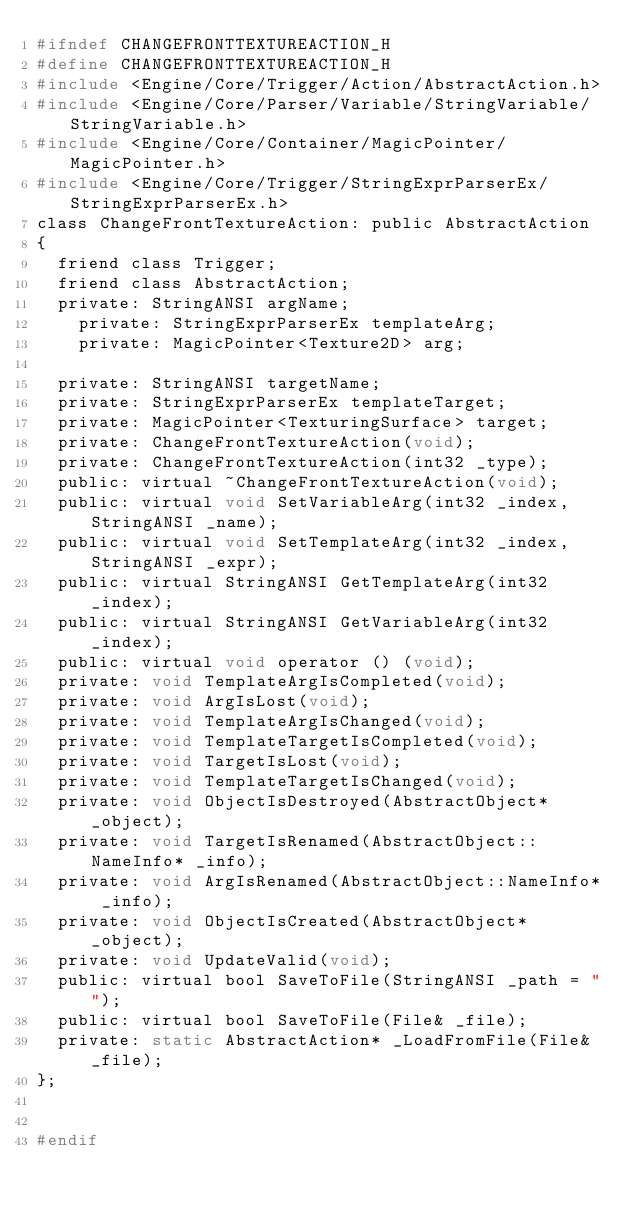Convert code to text. <code><loc_0><loc_0><loc_500><loc_500><_C_>#ifndef CHANGEFRONTTEXTUREACTION_H
#define CHANGEFRONTTEXTUREACTION_H
#include <Engine/Core/Trigger/Action/AbstractAction.h>
#include <Engine/Core/Parser/Variable/StringVariable/StringVariable.h>
#include <Engine/Core/Container/MagicPointer/MagicPointer.h>
#include <Engine/Core/Trigger/StringExprParserEx/StringExprParserEx.h>
class ChangeFrontTextureAction: public AbstractAction
{
	friend class Trigger;
	friend class AbstractAction;
	private: StringANSI argName;
    private: StringExprParserEx templateArg;
    private: MagicPointer<Texture2D> arg;

	private: StringANSI targetName;
	private: StringExprParserEx templateTarget;
	private: MagicPointer<TexturingSurface> target;
	private: ChangeFrontTextureAction(void);
	private: ChangeFrontTextureAction(int32 _type);
	public: virtual ~ChangeFrontTextureAction(void);
	public: virtual void SetVariableArg(int32 _index, StringANSI _name);
	public: virtual void SetTemplateArg(int32 _index, StringANSI _expr);
	public: virtual StringANSI GetTemplateArg(int32 _index);
	public: virtual StringANSI GetVariableArg(int32 _index);
	public: virtual void operator () (void);
	private: void TemplateArgIsCompleted(void);
	private: void ArgIsLost(void);
	private: void TemplateArgIsChanged(void);
	private: void TemplateTargetIsCompleted(void);
	private: void TargetIsLost(void);
	private: void TemplateTargetIsChanged(void);
	private: void ObjectIsDestroyed(AbstractObject* _object);
	private: void TargetIsRenamed(AbstractObject::NameInfo* _info);
	private: void ArgIsRenamed(AbstractObject::NameInfo* _info);
	private: void ObjectIsCreated(AbstractObject* _object);
	private: void UpdateValid(void);
	public: virtual bool SaveToFile(StringANSI _path = "");
	public: virtual bool SaveToFile(File& _file);
	private: static AbstractAction* _LoadFromFile(File& _file);
};


#endif </code> 